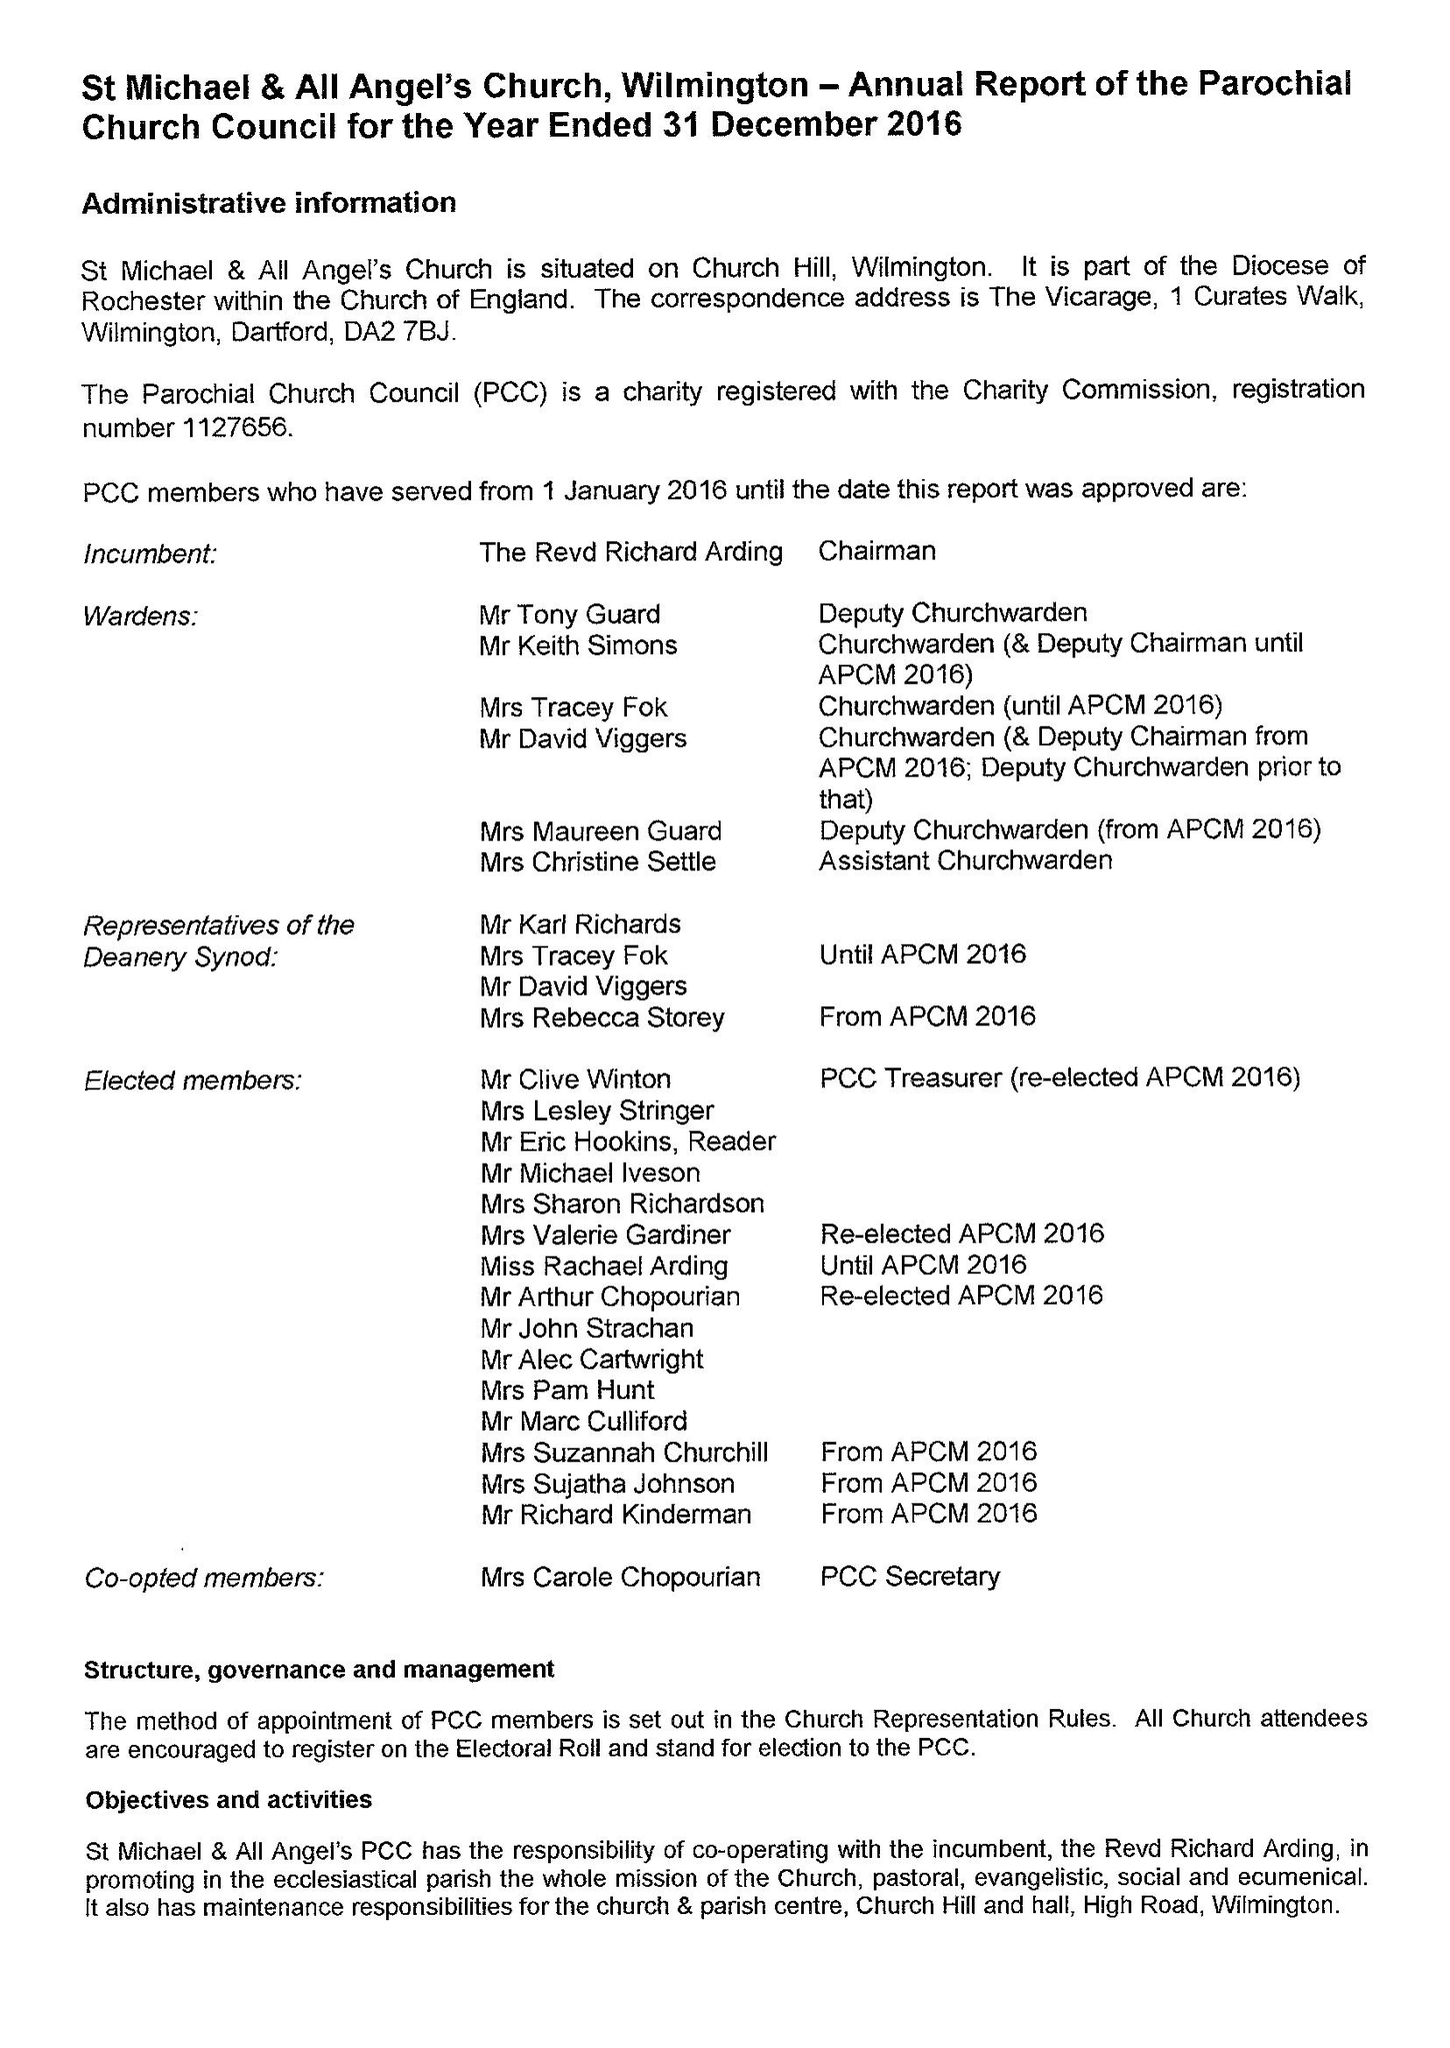What is the value for the address__post_town?
Answer the question using a single word or phrase. DARTFORD 